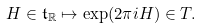<formula> <loc_0><loc_0><loc_500><loc_500>H \in \mathfrak t _ { \mathbb { R } } \mapsto \exp ( 2 \pi i H ) \in T .</formula> 